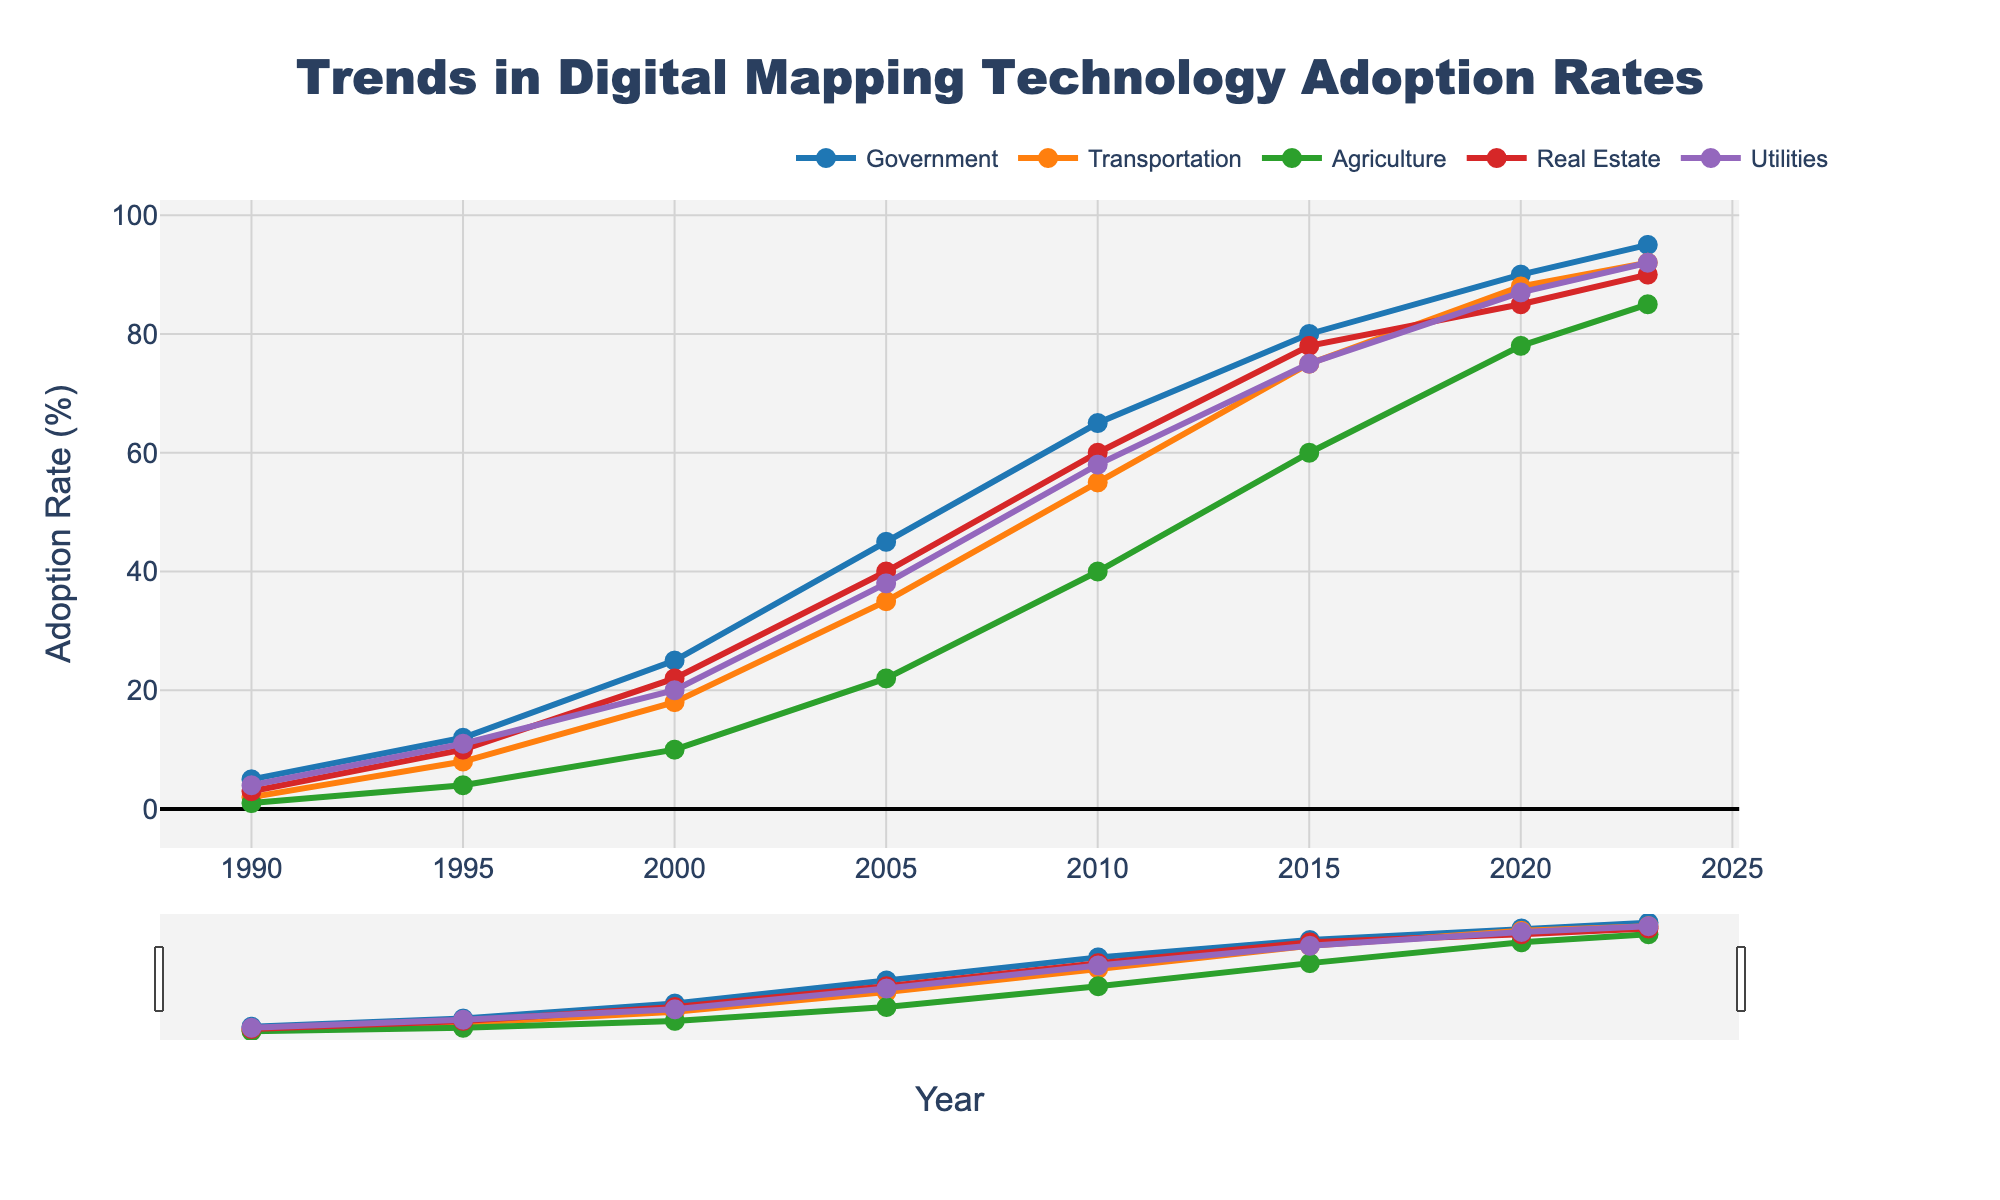Which industry had the highest adoption rate in 2005? Look at the values for each industry in 2005 and compare them. The Government industry had the highest adoption rate with a value of 45%.
Answer: Government By how much did the adoption rate in the Transportation industry increase between 1990 and 2020? Subtract the adoption rate in 1990 from the adoption rate in 2020 for the Transportation industry. The rate increased from 2% to 88%, resulting in an increase of 86%.
Answer: 86% What is the average adoption rate across all industries in 2023? Add the adoption rates across all industries in 2023 and then divide by the number of industries. (95 + 92 + 85 + 90 + 92) / 5 = 90.8%.
Answer: 90.8% Which industry showed the most consistent growth in adoption rates from 1990 to 2023? To determine this, examine the slope and increments of the lines representing each industry. The Government industry shows the most consistent upward trend with steady increments over the years.
Answer: Government Between 2000 and 2010, which industry had the smallest increase in adoption rates? Calculate the difference in adoption rates for each industry from 2000 to 2010. Agriculture increased the least, from 10% to 40%, a difference of 30%.
Answer: Agriculture In which year did the Real Estate industry surpass a 50% adoption rate? Observe the Real Estate line and find the point where it first crosses the 50% mark. This occurred in 2010.
Answer: 2010 Which industry had the lowest adoption rate in 1995? Examine the adoption rates for each industry in 1995 and identify the lowest value. Agriculture had the lowest adoption rate with 4%.
Answer: Agriculture By comparing the adoption rates of Utilities and Transportation in 2023, which industry has a higher rate and by how much? Check the adoption rates of both industries in 2023: Utilities is 92% and Transportation is 92%. Thus, they are equal with a difference of 0%.
Answer: Equal, 0% What was the total increase in the adoption rate for the Utilities industry from 1990 to 2023? Subtract the rate in 1990 from the rate in 2023 for the Utilities industry: 92% - 4% = 88%.
Answer: 88% 